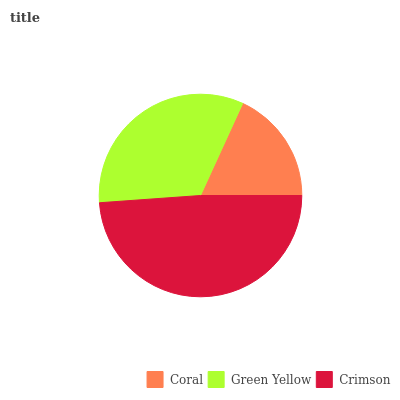Is Coral the minimum?
Answer yes or no. Yes. Is Crimson the maximum?
Answer yes or no. Yes. Is Green Yellow the minimum?
Answer yes or no. No. Is Green Yellow the maximum?
Answer yes or no. No. Is Green Yellow greater than Coral?
Answer yes or no. Yes. Is Coral less than Green Yellow?
Answer yes or no. Yes. Is Coral greater than Green Yellow?
Answer yes or no. No. Is Green Yellow less than Coral?
Answer yes or no. No. Is Green Yellow the high median?
Answer yes or no. Yes. Is Green Yellow the low median?
Answer yes or no. Yes. Is Crimson the high median?
Answer yes or no. No. Is Crimson the low median?
Answer yes or no. No. 